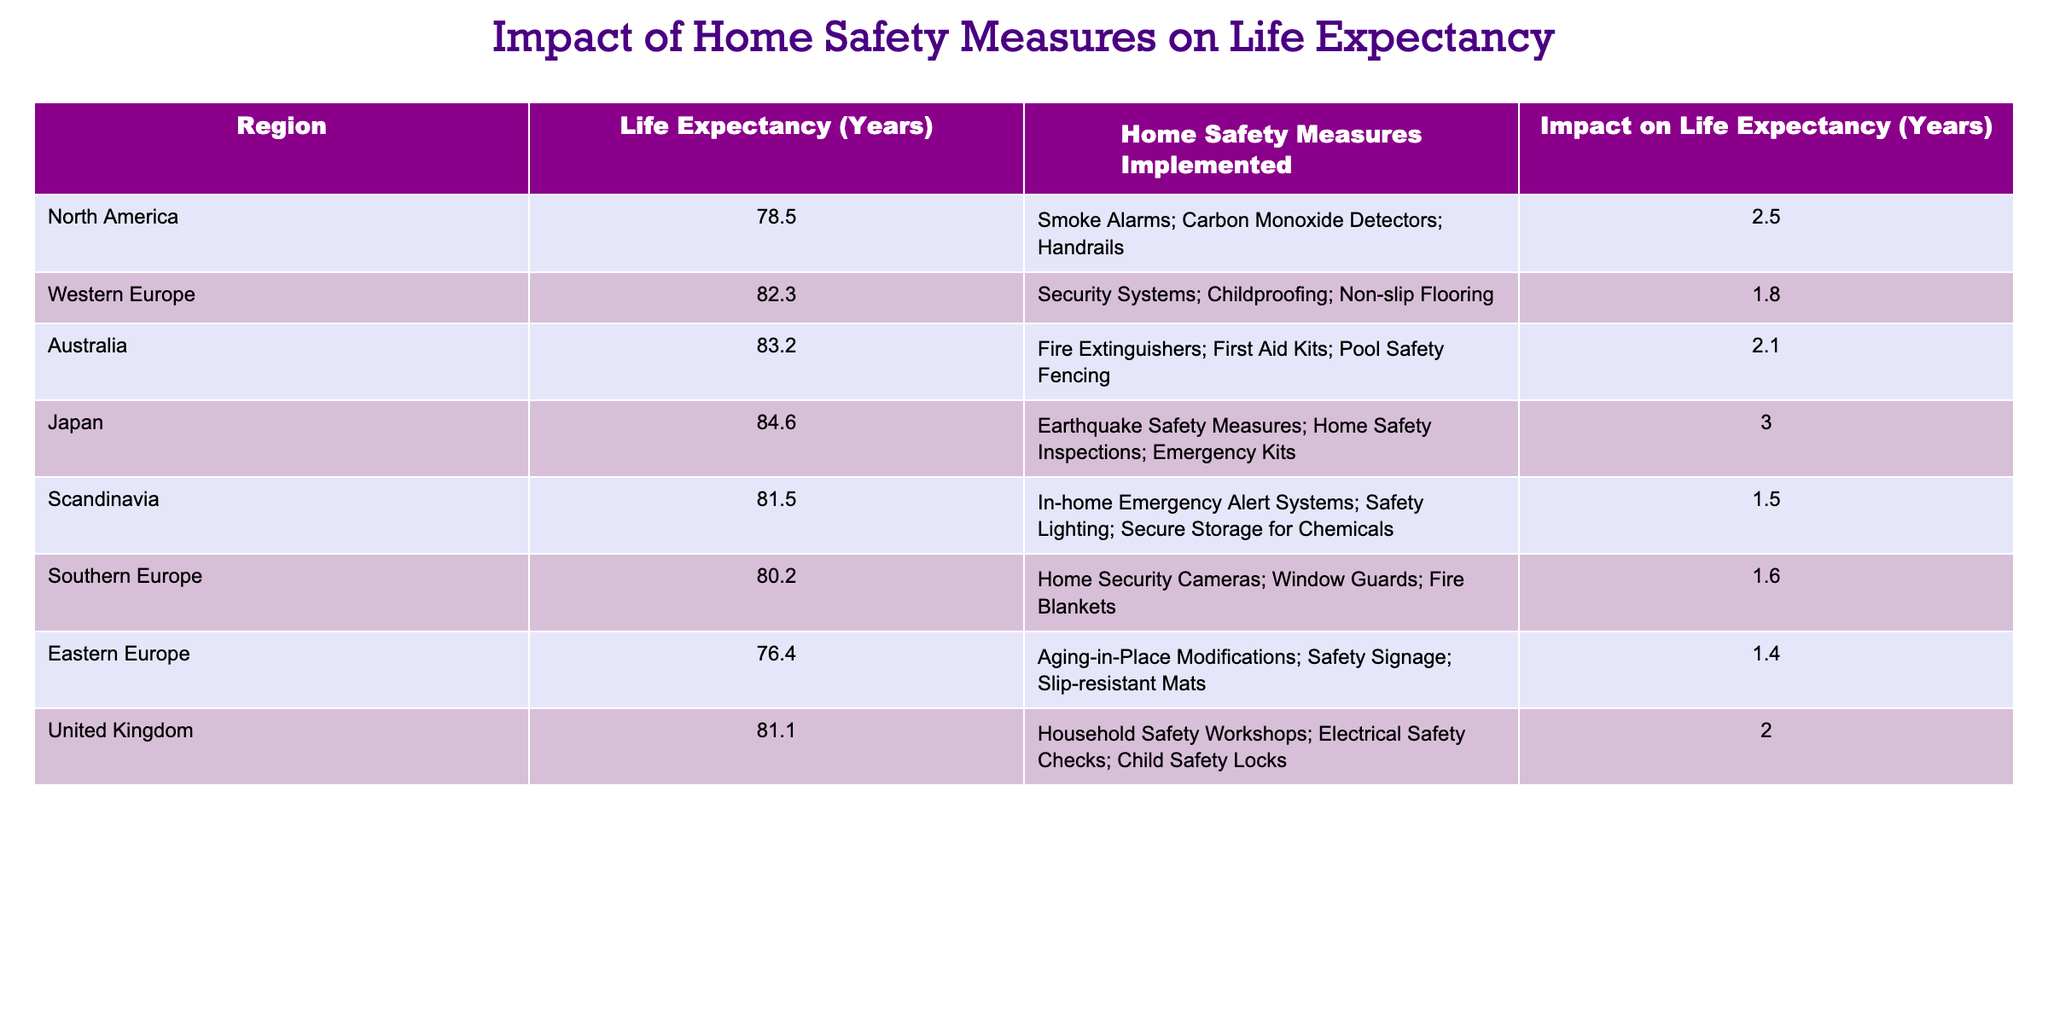What region has the highest life expectancy? By examining the Life Expectancy (Years) column, the region with the highest value is Japan at 84.6 years.
Answer: Japan How many years does the implementation of home safety measures increase life expectancy in Canada? Canada is part of North America, which has a life expectancy of 78.5 years and an increase of 2.5 years from home safety measures. Thus, the life expectancy after implementation would be 78.5 + 2.5 = 81.0 years.
Answer: 81.0 True or false: Home safety measures have a greater impact on life expectancy in Australia than in Western Europe. In Australia, the impact is 2.1 years, while in Western Europe it is 1.8 years. Since 2.1 > 1.8, the statement is true.
Answer: True What is the average increase in life expectancy from home safety measures for the regions listed? To find the average: add the impacts: (2.5 + 1.8 + 2.1 + 3.0 + 1.5 + 1.6 + 1.4 + 2.0) = 14.0 years. There are 8 regions, so divide 14.0 by 8 to get the average: 14.0 / 8 = 1.75 years.
Answer: 1.75 Which region shows the least impact from home safety measures? By looking at the Impact on Life Expectancy (Years) column, Eastern Europe shows the least impact at 1.4 years.
Answer: Eastern Europe How much more does home safety measures increase life expectancy in Japan compared to Scandinavia? Japan has an impact of 3.0 years, while Scandinavia has an impact of 1.5 years. The difference is 3.0 - 1.5 = 1.5 years.
Answer: 1.5 True or false: The average life expectancy in the table is above 80 years. Adding the life expectancies: (78.5 + 82.3 + 83.2 + 84.6 + 81.5 + 80.2 + 76.4 + 81.1) = 468.8. There are 8 regions, so the average is 468.8 / 8 = 58.6, which is below 80. Therefore, the statement is false.
Answer: False What region has implemented childproofing as a home safety measure, and how much does it impact life expectancy? Western Europe has implemented childproofing, and it increases life expectancy by 1.8 years.
Answer: Western Europe, 1.8 years 